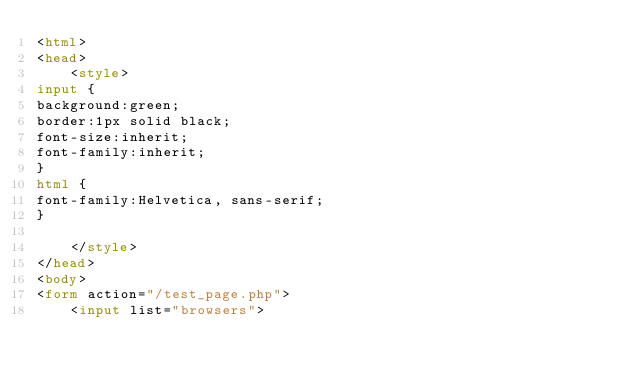<code> <loc_0><loc_0><loc_500><loc_500><_HTML_><html>
<head>
    <style>
input {
background:green;
border:1px solid black;
font-size:inherit;
font-family:inherit;
}
html {
font-family:Helvetica, sans-serif;
}

    </style>
</head>
<body>
<form action="/test_page.php">
    <input list="browsers"></code> 